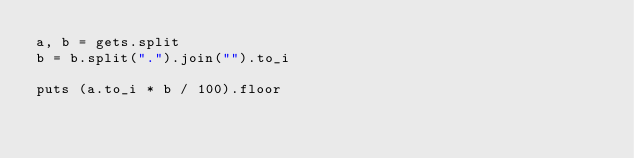Convert code to text. <code><loc_0><loc_0><loc_500><loc_500><_Ruby_>a, b = gets.split
b = b.split(".").join("").to_i

puts (a.to_i * b / 100).floor
</code> 